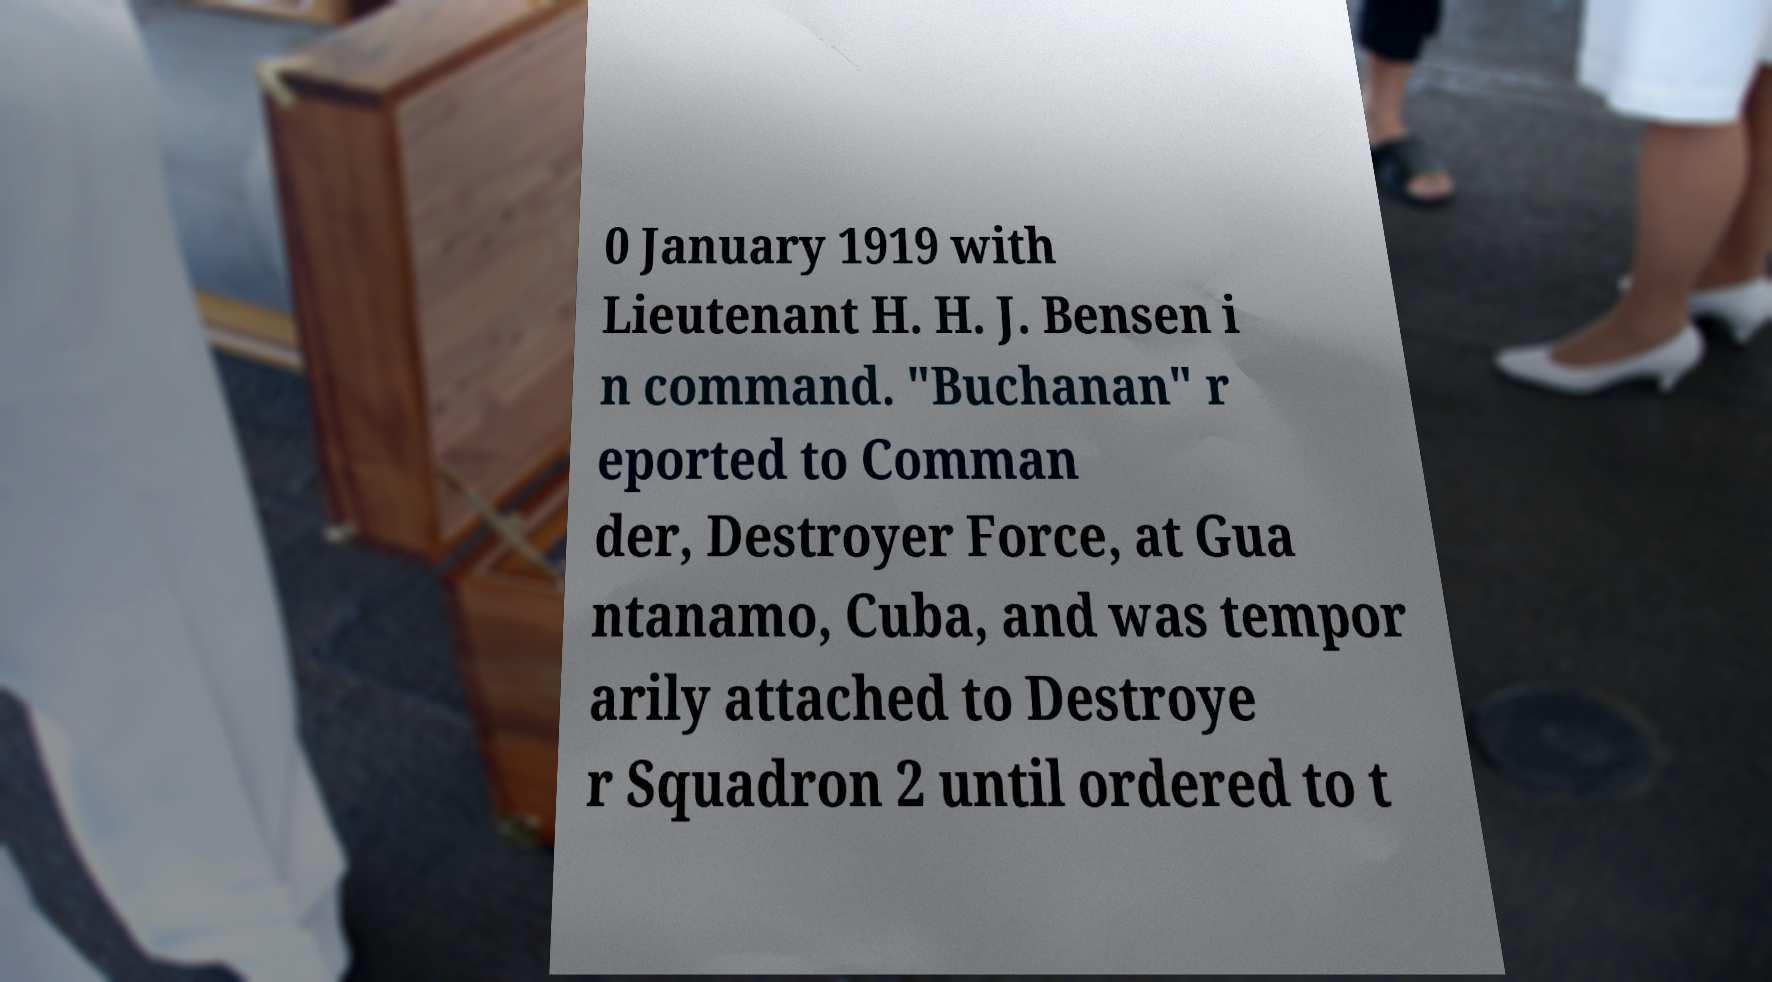For documentation purposes, I need the text within this image transcribed. Could you provide that? 0 January 1919 with Lieutenant H. H. J. Bensen i n command. "Buchanan" r eported to Comman der, Destroyer Force, at Gua ntanamo, Cuba, and was tempor arily attached to Destroye r Squadron 2 until ordered to t 